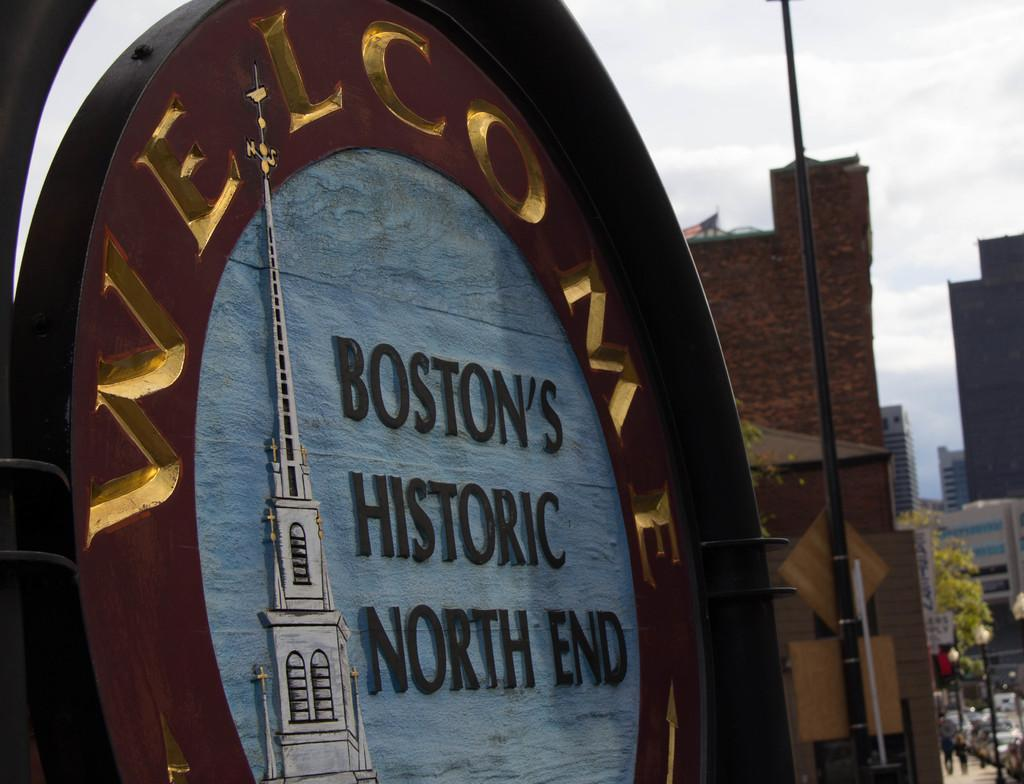What is the name of the street that can be seen in the image? The name of the street is visible in the image. What can be found on the street in the image? There is a pole, buildings, vehicles, two people on the pavement, trees, and the sky visible in the image. How many people are present on the pavement in the image? There are two people on the pavement in the image. What is the purpose of the rabbit in the image? There is no rabbit present in the image, so it is not possible to determine its purpose. 